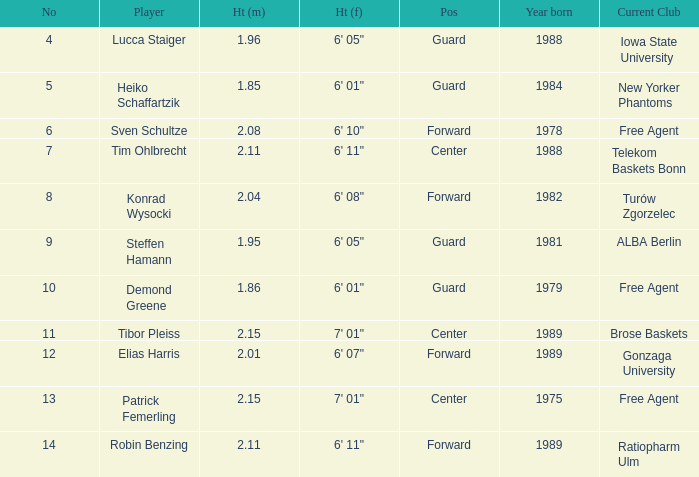85 m? Heiko Schaffartzik. 